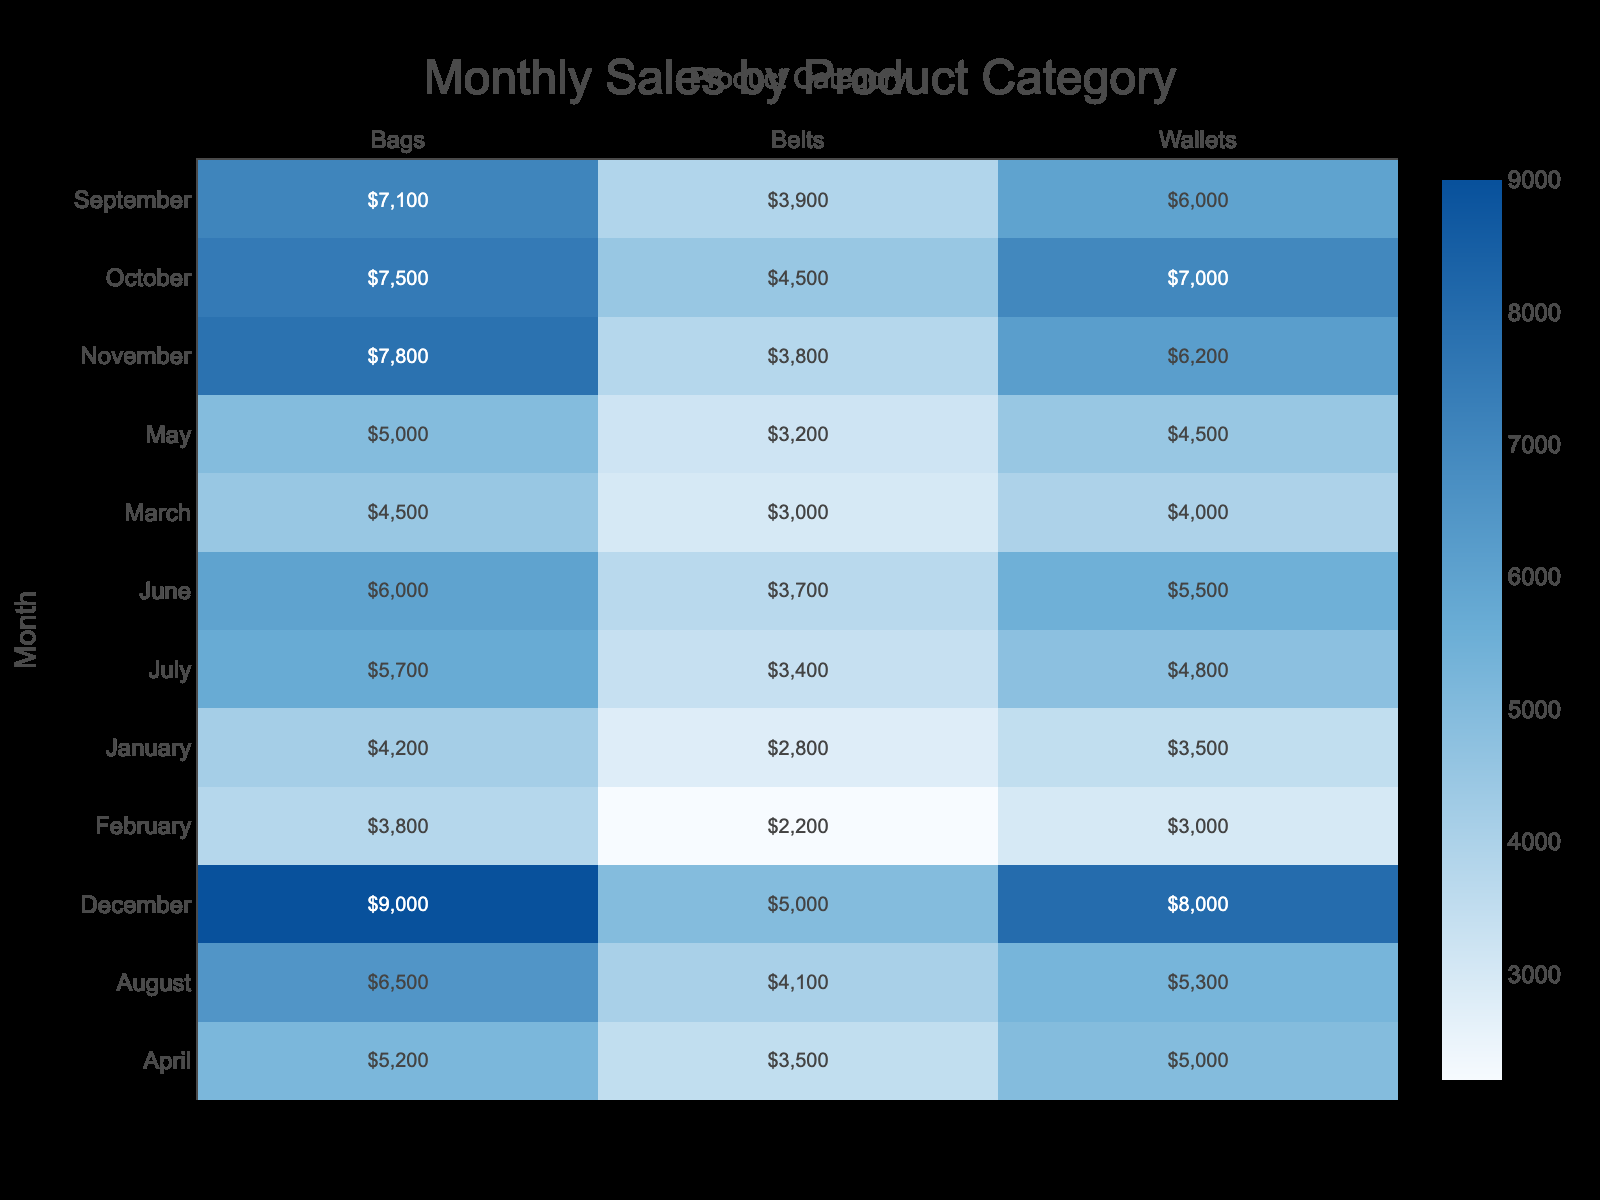What was the total sales of Bags in March? Referring to the table, in March, the total sales for Bags is listed as 4500.
Answer: 4500 What is the average total sales for Wallets across the months? We add the total sales of Wallets for all months: (3500 + 3000 + 4000 + 5000 + 4500 + 5500 + 4800 + 5300 + 6000 + 7000 + 6200 + 8000) = 60,000. Then we divide by 12 months, which equals 60,000 / 12 = 5000.
Answer: 5000 Did total sales for Belts ever exceed 4000? By examining the entries for Belts in the table, the highest total sales recorded is 3800 in November, which means total sales for Belts never exceeded 4000.
Answer: No Which month had the highest total sales for Bags, and what was the amount? By inspecting the monthly sales data for Bags, December shows the highest total sales of 9000.
Answer: December, 9000 If we combine the total sales of Wallets and Bags in June, what is the total? Total sales for Wallets in June is 5500, and for Bags is 6000. The combined total is 5500 + 6000 = 11500.
Answer: 11500 What is the total sales of all categories combined in October? The total sales in October for each category are as follows: Wallets 7000, Bags 7500, and Belts 4500. Adding these values gives us: 7000 + 7500 + 4500 = 19000.
Answer: 19000 In which month did the total sales of Wallets increase by the most compared to the previous month? By checking the total sales month over month for Wallets, we see that from April (5000) to May (4500), there is a decrease; however, from March (4000) to April (5000), there is an increase of 1000. Thus, the highest increase is from March to April.
Answer: March to April Was the average price of Bags higher in January or February? The average price for Bags was 150 in January and 158.33 in February. Since 158.33 > 150, February had a higher average price.
Answer: February 